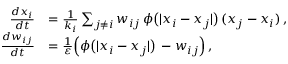Convert formula to latex. <formula><loc_0><loc_0><loc_500><loc_500>\begin{array} { r l } { \frac { d x _ { i } } { d t } } & { = \frac { 1 } { k _ { i } } \sum _ { j \neq i } w _ { i j } \, \phi \left ( | x _ { i } - x _ { j } | \right ) \, ( x _ { j } - x _ { i } ) \, , } \\ { \frac { d w _ { i j } } { d t } } & { = \frac { 1 } { \varepsilon } \left ( \phi \left ( | x _ { i } - x _ { j } | \right ) \, - w _ { i j } \right ) \, , } \end{array}</formula> 